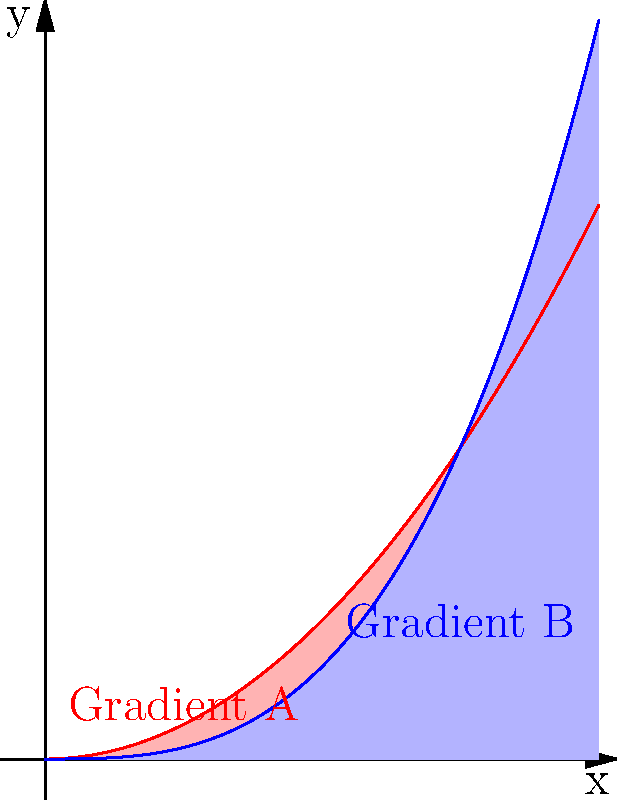In digital fabric print analysis, which mathematical function would be more suitable for detecting smooth color transitions in a gradient that starts slowly but intensifies rapidly towards the end? To determine the most suitable function for detecting smooth color transitions in a gradient with the described behavior, let's analyze the two functions represented in the graph:

1. Gradient A (red curve): This is a quadratic function, $f(x) = 0.5x^2$
2. Gradient B (blue curve): This is a cubic function, $g(x) = \frac{x^3}{3}$

Step 1: Analyze the behavior of each function
- Quadratic function (A): Increases at a constant rate (linear slope increase)
- Cubic function (B): Increases slowly at first, then accelerates more rapidly

Step 2: Compare to the desired gradient behavior
The question asks for a gradient that "starts slowly but intensifies rapidly towards the end."

Step 3: Evaluate which function matches the description
- Gradient A (quadratic) increases steadily, not matching the desired behavior
- Gradient B (cubic) starts slowly and then intensifies rapidly, matching the description

Step 4: Consider the implications for color transitions
The cubic function (B) would represent a smooth transition that becomes more pronounced towards the end of the gradient, which is ideal for detecting color changes that intensify rapidly in digital fabric prints.
Answer: Cubic function (Gradient B) 